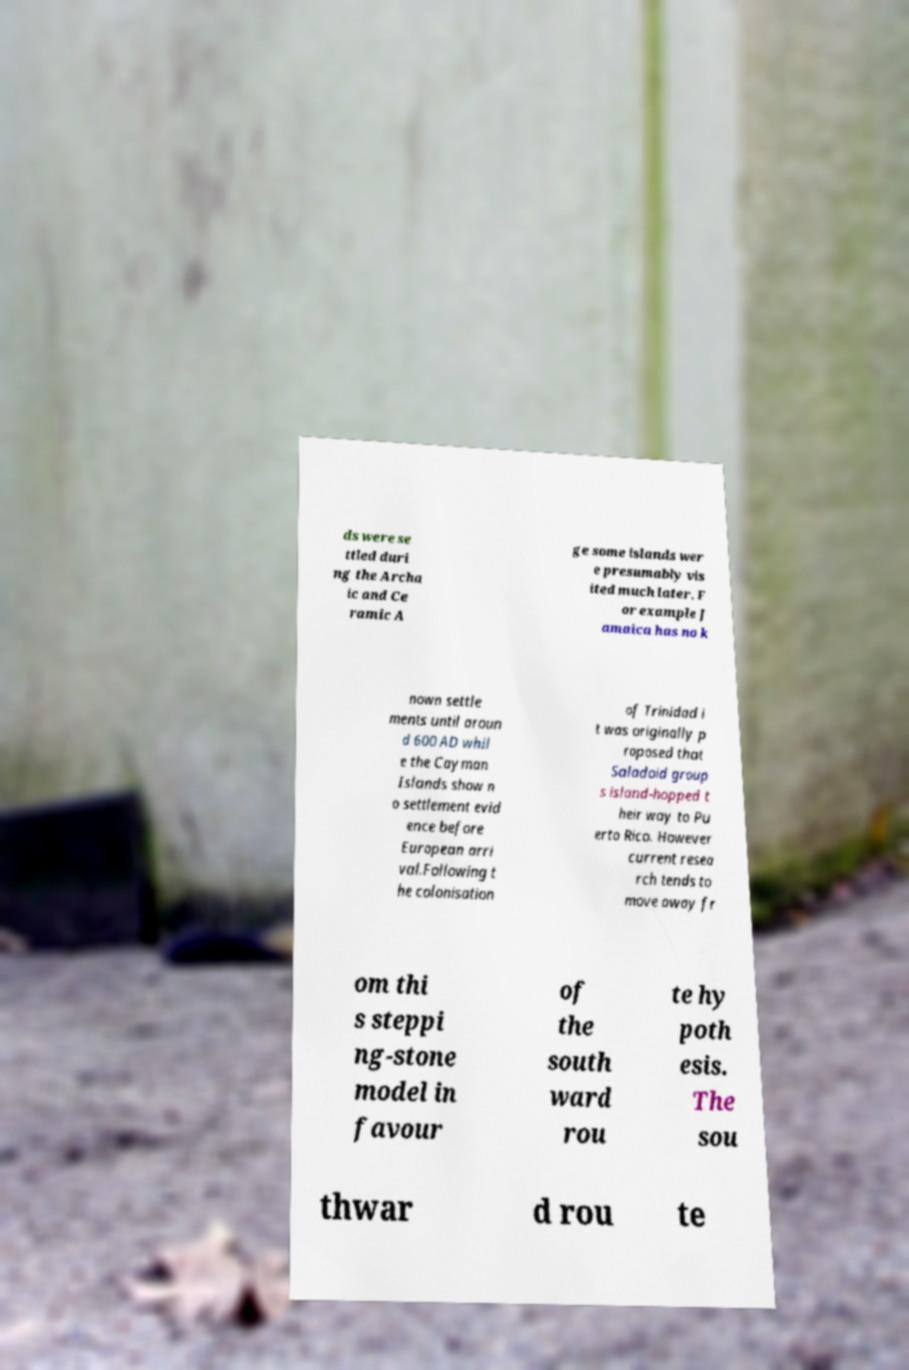For documentation purposes, I need the text within this image transcribed. Could you provide that? ds were se ttled duri ng the Archa ic and Ce ramic A ge some islands wer e presumably vis ited much later. F or example J amaica has no k nown settle ments until aroun d 600 AD whil e the Cayman Islands show n o settlement evid ence before European arri val.Following t he colonisation of Trinidad i t was originally p roposed that Saladoid group s island-hopped t heir way to Pu erto Rico. However current resea rch tends to move away fr om thi s steppi ng-stone model in favour of the south ward rou te hy poth esis. The sou thwar d rou te 